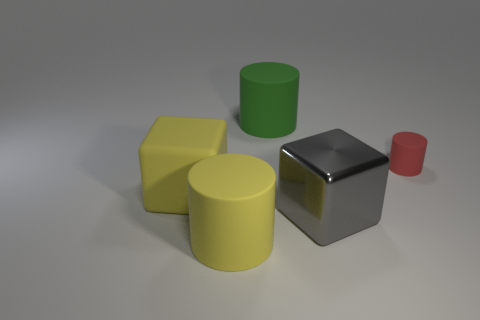Is there any other thing that is made of the same material as the big gray cube?
Give a very brief answer. No. Does the cube on the right side of the yellow cylinder have the same color as the cylinder to the right of the gray block?
Your response must be concise. No. There is a block that is on the left side of the yellow matte thing on the right side of the large cube that is to the left of the big shiny object; what is it made of?
Offer a terse response. Rubber. Are there more yellow matte cubes than objects?
Make the answer very short. No. Are there any other things that have the same color as the big metal object?
Make the answer very short. No. What is the size of the red cylinder that is made of the same material as the large green cylinder?
Offer a very short reply. Small. What is the material of the big yellow cylinder?
Provide a short and direct response. Rubber. How many other rubber cylinders are the same size as the red cylinder?
Make the answer very short. 0. The thing that is the same color as the large matte block is what shape?
Make the answer very short. Cylinder. Are there any other red things that have the same shape as the small object?
Provide a succinct answer. No. 